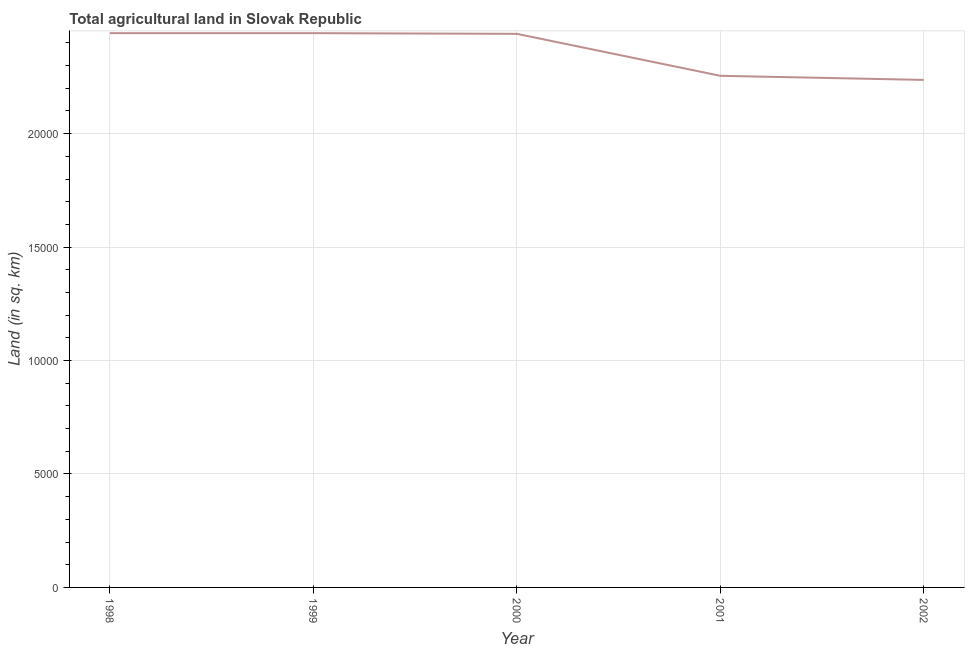What is the agricultural land in 2001?
Keep it short and to the point. 2.26e+04. Across all years, what is the maximum agricultural land?
Offer a very short reply. 2.44e+04. Across all years, what is the minimum agricultural land?
Keep it short and to the point. 2.24e+04. In which year was the agricultural land maximum?
Make the answer very short. 1998. In which year was the agricultural land minimum?
Give a very brief answer. 2002. What is the sum of the agricultural land?
Ensure brevity in your answer.  1.18e+05. What is the difference between the agricultural land in 1998 and 2001?
Your answer should be compact. 1880. What is the average agricultural land per year?
Your answer should be compact. 2.36e+04. What is the median agricultural land?
Ensure brevity in your answer.  2.44e+04. What is the ratio of the agricultural land in 1998 to that in 2002?
Make the answer very short. 1.09. Is the agricultural land in 1999 less than that in 2000?
Offer a terse response. No. What is the difference between the highest and the second highest agricultural land?
Provide a succinct answer. 0. What is the difference between the highest and the lowest agricultural land?
Keep it short and to the point. 2060. In how many years, is the agricultural land greater than the average agricultural land taken over all years?
Give a very brief answer. 3. How many years are there in the graph?
Give a very brief answer. 5. Are the values on the major ticks of Y-axis written in scientific E-notation?
Keep it short and to the point. No. What is the title of the graph?
Offer a very short reply. Total agricultural land in Slovak Republic. What is the label or title of the X-axis?
Give a very brief answer. Year. What is the label or title of the Y-axis?
Keep it short and to the point. Land (in sq. km). What is the Land (in sq. km) of 1998?
Give a very brief answer. 2.44e+04. What is the Land (in sq. km) of 1999?
Offer a terse response. 2.44e+04. What is the Land (in sq. km) in 2000?
Provide a short and direct response. 2.44e+04. What is the Land (in sq. km) of 2001?
Your response must be concise. 2.26e+04. What is the Land (in sq. km) of 2002?
Provide a short and direct response. 2.24e+04. What is the difference between the Land (in sq. km) in 1998 and 1999?
Offer a very short reply. 0. What is the difference between the Land (in sq. km) in 1998 and 2000?
Offer a very short reply. 30. What is the difference between the Land (in sq. km) in 1998 and 2001?
Offer a terse response. 1880. What is the difference between the Land (in sq. km) in 1998 and 2002?
Offer a terse response. 2060. What is the difference between the Land (in sq. km) in 1999 and 2001?
Provide a short and direct response. 1880. What is the difference between the Land (in sq. km) in 1999 and 2002?
Keep it short and to the point. 2060. What is the difference between the Land (in sq. km) in 2000 and 2001?
Ensure brevity in your answer.  1850. What is the difference between the Land (in sq. km) in 2000 and 2002?
Ensure brevity in your answer.  2030. What is the difference between the Land (in sq. km) in 2001 and 2002?
Your answer should be compact. 180. What is the ratio of the Land (in sq. km) in 1998 to that in 1999?
Provide a short and direct response. 1. What is the ratio of the Land (in sq. km) in 1998 to that in 2001?
Your answer should be very brief. 1.08. What is the ratio of the Land (in sq. km) in 1998 to that in 2002?
Provide a succinct answer. 1.09. What is the ratio of the Land (in sq. km) in 1999 to that in 2001?
Give a very brief answer. 1.08. What is the ratio of the Land (in sq. km) in 1999 to that in 2002?
Ensure brevity in your answer.  1.09. What is the ratio of the Land (in sq. km) in 2000 to that in 2001?
Keep it short and to the point. 1.08. What is the ratio of the Land (in sq. km) in 2000 to that in 2002?
Offer a very short reply. 1.09. What is the ratio of the Land (in sq. km) in 2001 to that in 2002?
Your answer should be very brief. 1.01. 